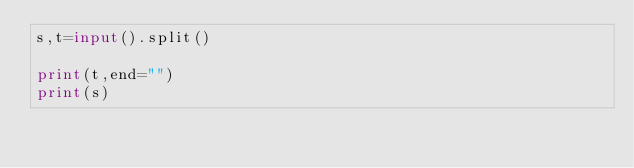Convert code to text. <code><loc_0><loc_0><loc_500><loc_500><_Python_>s,t=input().split()

print(t,end="")
print(s)</code> 